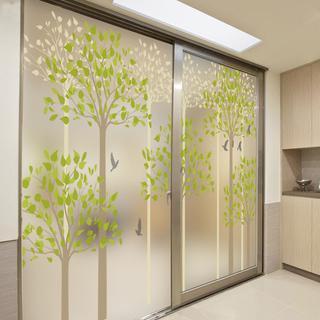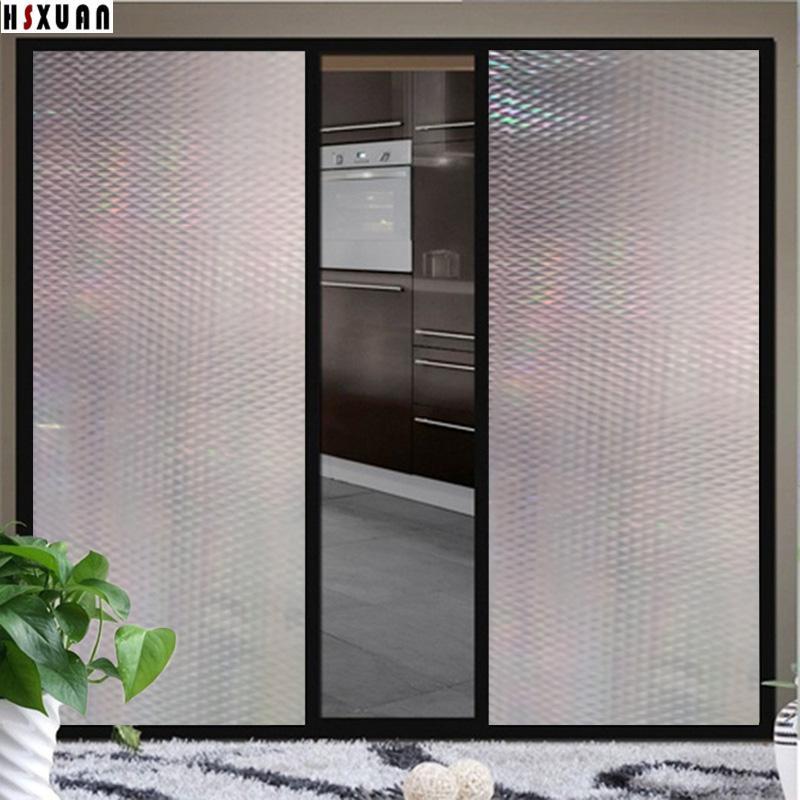The first image is the image on the left, the second image is the image on the right. Examine the images to the left and right. Is the description "Both images contain an object with a plant design on it." accurate? Answer yes or no. No. 